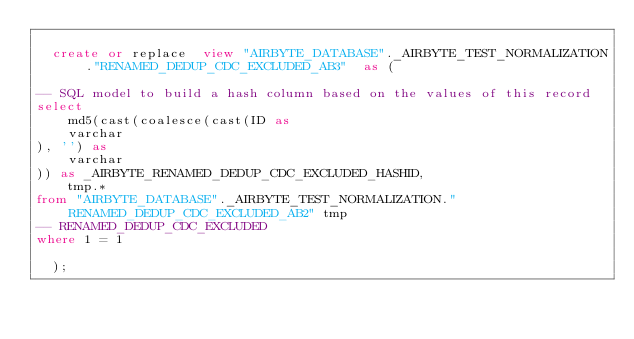Convert code to text. <code><loc_0><loc_0><loc_500><loc_500><_SQL_>
  create or replace  view "AIRBYTE_DATABASE"._AIRBYTE_TEST_NORMALIZATION."RENAMED_DEDUP_CDC_EXCLUDED_AB3"  as (
    
-- SQL model to build a hash column based on the values of this record
select
    md5(cast(coalesce(cast(ID as 
    varchar
), '') as 
    varchar
)) as _AIRBYTE_RENAMED_DEDUP_CDC_EXCLUDED_HASHID,
    tmp.*
from "AIRBYTE_DATABASE"._AIRBYTE_TEST_NORMALIZATION."RENAMED_DEDUP_CDC_EXCLUDED_AB2" tmp
-- RENAMED_DEDUP_CDC_EXCLUDED
where 1 = 1

  );
</code> 